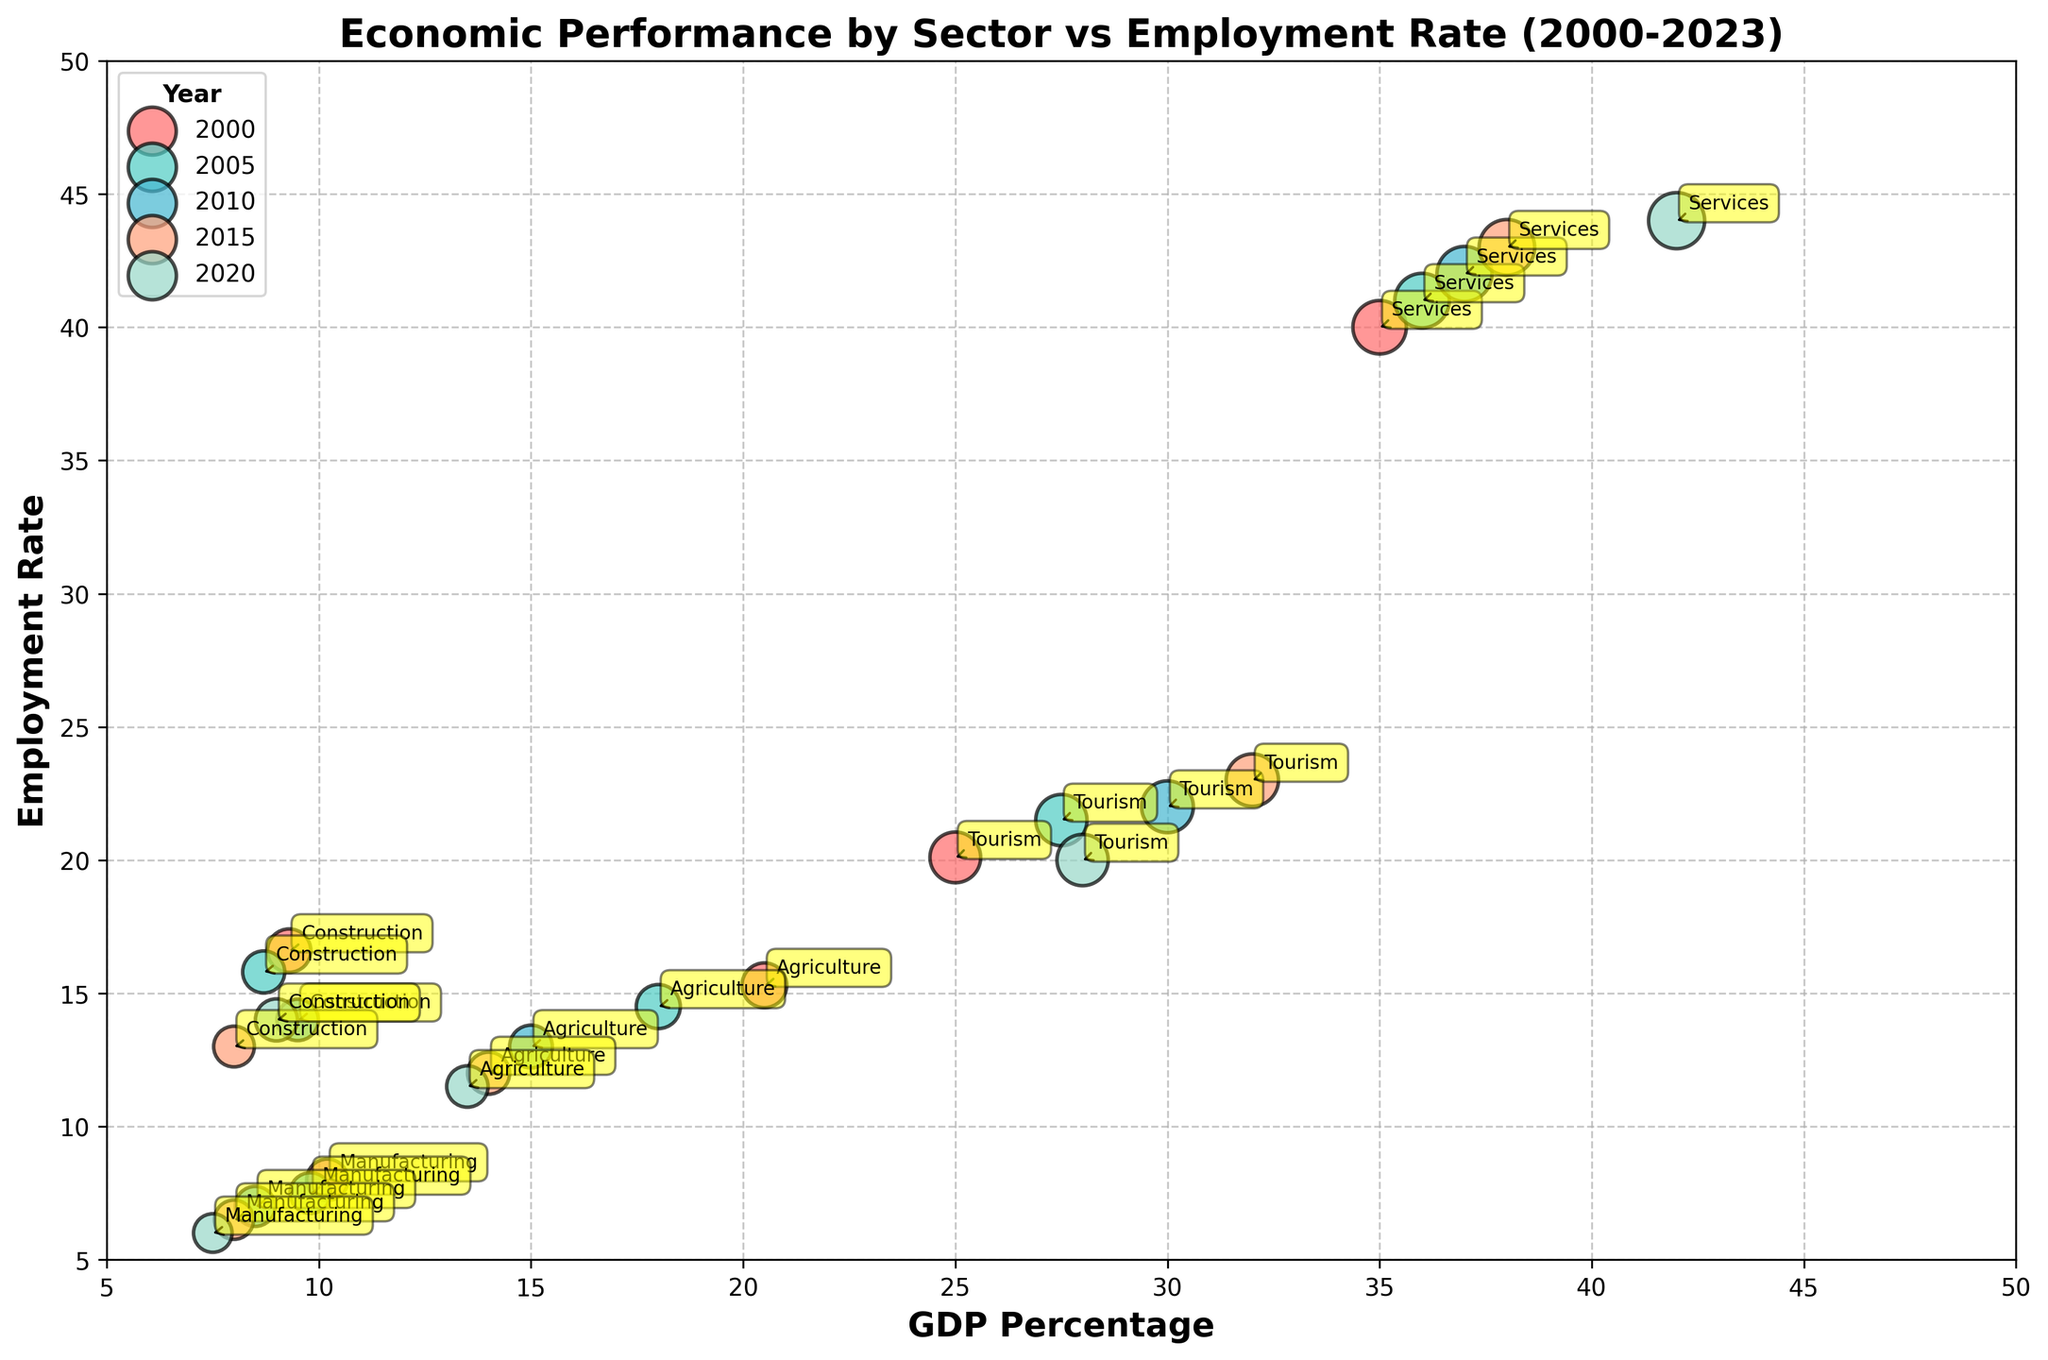Which sector had the highest GDP percentage in 2023? Look at the data points for 2023, focusing on the GDP percentage values, and identify the highest one.
Answer: Services (45.0) How has the GDP percentage of the Agriculture sector changed from 2000 to 2023? Compare the GDP percentage of Agriculture in 2000 (20.5) with that in 2023 (12.0).
Answer: Decreased Which year shows the highest employment rate in the Services sector? Look at the bubble corresponding to the Services sector across different years and identify the one with the highest employment rate.
Answer: 2023 Among the five sectors in 2010, which one had the second-highest employment rate? Examine the employment rates of all sectors in the year 2010 and identify the second-highest value.
Answer: Tourism (22.0) What is the average employment rate across all sectors in 2023? Sum up the employment rates for all sectors in 2023 and divide by the number of sectors (5). Calculation: (11.0 + 5.5 + 19.0 + 45.0 + 13.5) / 5 = 18.8
Answer: 18.8 Which sector in 2023 had a lower employment rate than it had in 2020? Compare the employment rates for each sector in 2023 to their respective values in 2020.
Answer: Tourism (19.0 in 2023 vs. 20.0 in 2020) For the year 2015, which sector had the smallest bubble size? Examine the bubble sizes for different sectors in 2015 and identify the smallest one.
Answer: Construction (290) What is the trend in GDP percentage for the Manufacturing sector from 2000 to 2023? Observe the values of GDP percentage for Manufacturing from 2000 to 2023 (10.2, 9.8, 8.5, 8.0, 7.5, 7.0) to identify the trend.
Answer: Decreasing Which sector had no change in its GDP percentage from 2020 to 2023? Compare the GDP percentages for each sector between 2020 and 2023 and identify which one remained constant.
Answer: Construction (9.5) What is the difference in employment rate between Tourism and Manufacturing in 2020? Subtract the employment rate of Manufacturing from Tourism for the year 2020. Calculation: 20.0 - 6.0 = 14.0
Answer: 14.0 